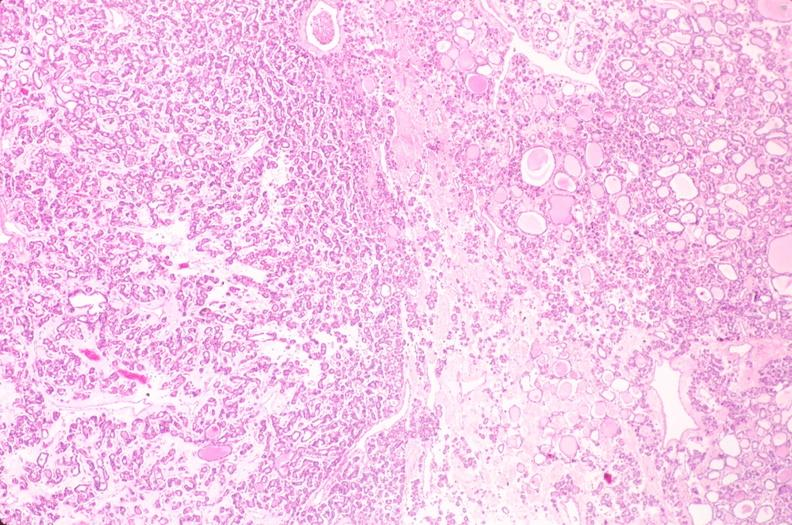what does this image show?
Answer the question using a single word or phrase. Thyroid 